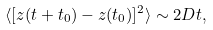Convert formula to latex. <formula><loc_0><loc_0><loc_500><loc_500>\langle [ z ( t + t _ { 0 } ) - z ( t _ { 0 } ) ] ^ { 2 } \rangle \sim 2 D t ,</formula> 